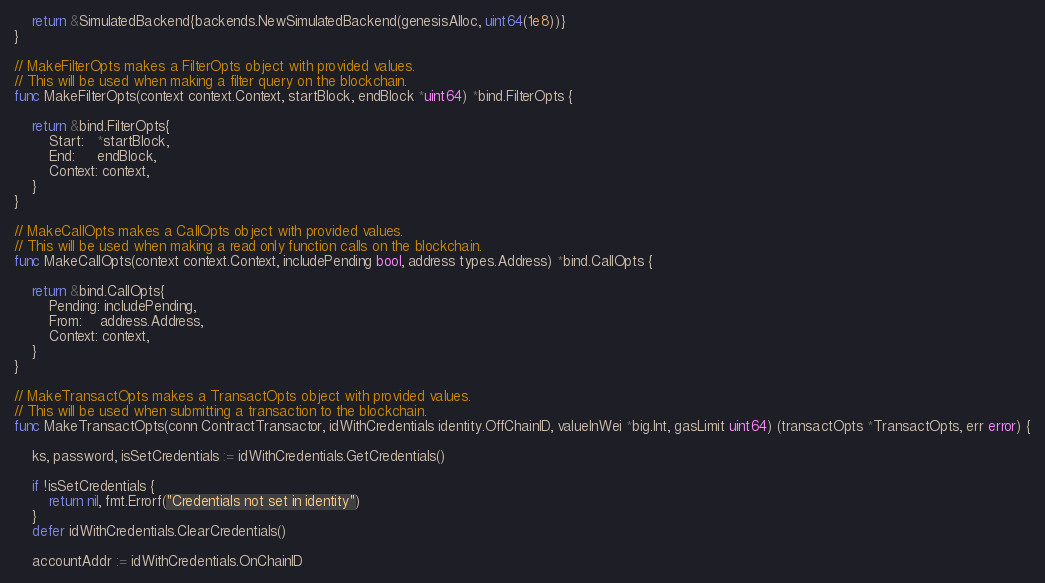<code> <loc_0><loc_0><loc_500><loc_500><_Go_>	return &SimulatedBackend{backends.NewSimulatedBackend(genesisAlloc, uint64(1e8))}
}

// MakeFilterOpts makes a FilterOpts object with provided values.
// This will be used when making a filter query on the blockchain.
func MakeFilterOpts(context context.Context, startBlock, endBlock *uint64) *bind.FilterOpts {

	return &bind.FilterOpts{
		Start:   *startBlock,
		End:     endBlock,
		Context: context,
	}
}

// MakeCallOpts makes a CallOpts object with provided values.
// This will be used when making a read only function calls on the blockchain.
func MakeCallOpts(context context.Context, includePending bool, address types.Address) *bind.CallOpts {

	return &bind.CallOpts{
		Pending: includePending,
		From:    address.Address,
		Context: context,
	}
}

// MakeTransactOpts makes a TransactOpts object with provided values.
// This will be used when submitting a transaction to the blockchain.
func MakeTransactOpts(conn ContractTransactor, idWithCredentials identity.OffChainID, valueInWei *big.Int, gasLimit uint64) (transactOpts *TransactOpts, err error) {

	ks, password, isSetCredentials := idWithCredentials.GetCredentials()

	if !isSetCredentials {
		return nil, fmt.Errorf("Credentials not set in identity")
	}
	defer idWithCredentials.ClearCredentials()

	accountAddr := idWithCredentials.OnChainID</code> 